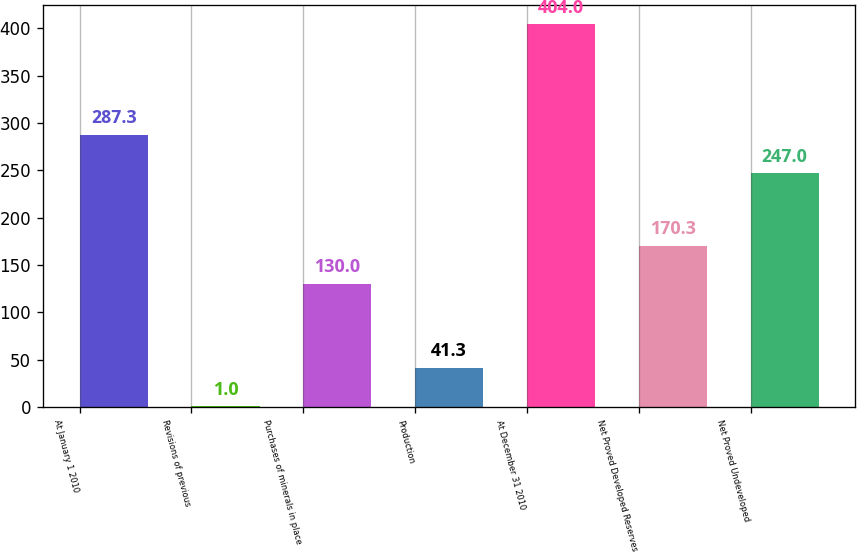Convert chart to OTSL. <chart><loc_0><loc_0><loc_500><loc_500><bar_chart><fcel>At January 1 2010<fcel>Revisions of previous<fcel>Purchases of minerals in place<fcel>Production<fcel>At December 31 2010<fcel>Net Proved Developed Reserves<fcel>Net Proved Undeveloped<nl><fcel>287.3<fcel>1<fcel>130<fcel>41.3<fcel>404<fcel>170.3<fcel>247<nl></chart> 